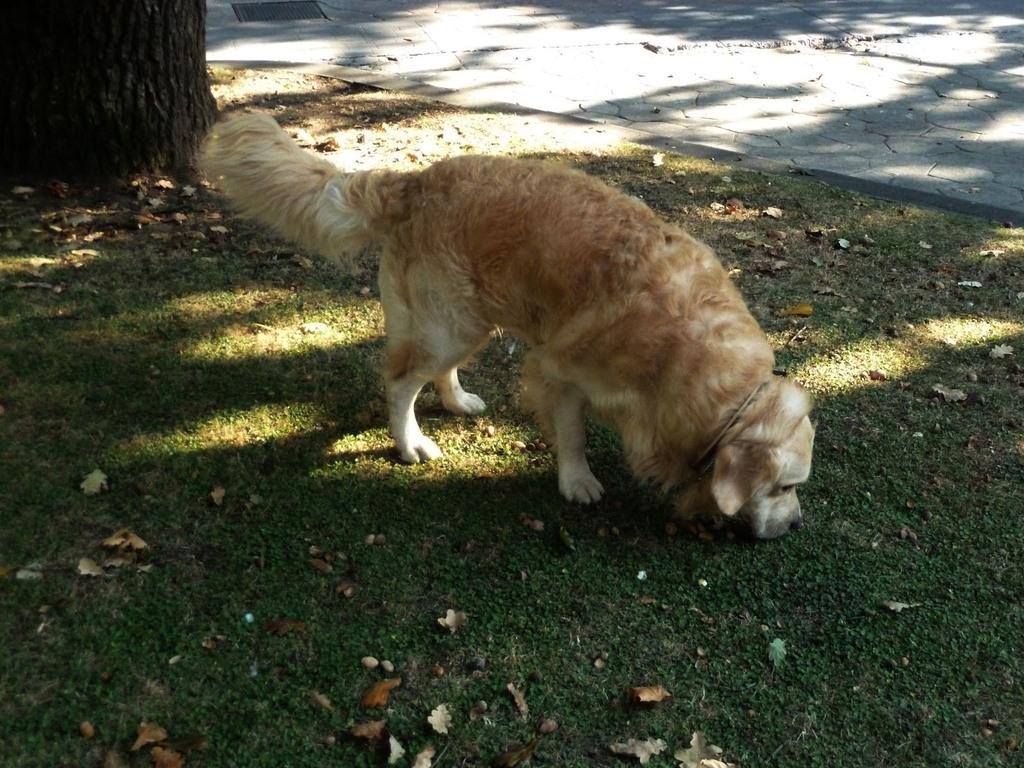What animal is present in the image? There is a dog in the image. What is the dog's position in the image? The dog is standing on the ground. What can be seen in the background of the image? There is a tree and grass in the background of the image. What is present on the ground in the image? Leaves are present on the ground in the image. Can you describe the moment when the dog exchanges a kiss with the tree in the image? There is no moment in the image where the dog exchanges a kiss with the tree, as the dog is standing on the ground and the tree is in the background. 